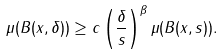Convert formula to latex. <formula><loc_0><loc_0><loc_500><loc_500>\mu ( B ( x , \delta ) ) \geq c \left ( \frac { \delta } { s } \right ) ^ { \beta } \mu ( B ( x , s ) ) .</formula> 